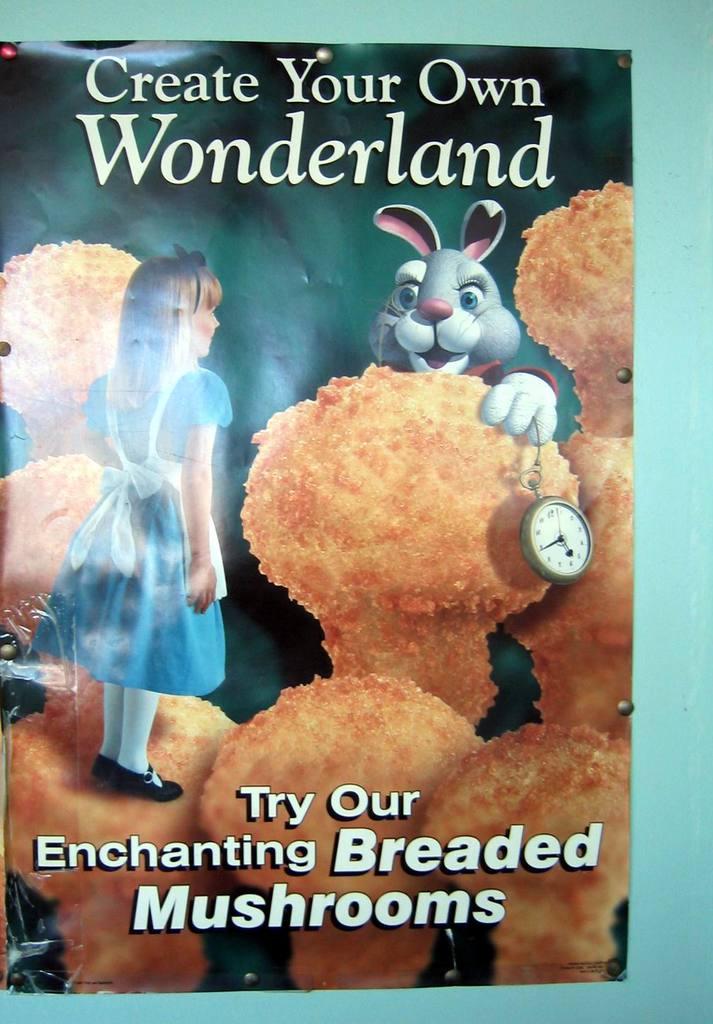What kind of mushrooms are being advertised?
Give a very brief answer. Breaded. What type of food is on the poster?
Keep it short and to the point. Breaded mushrooms. 